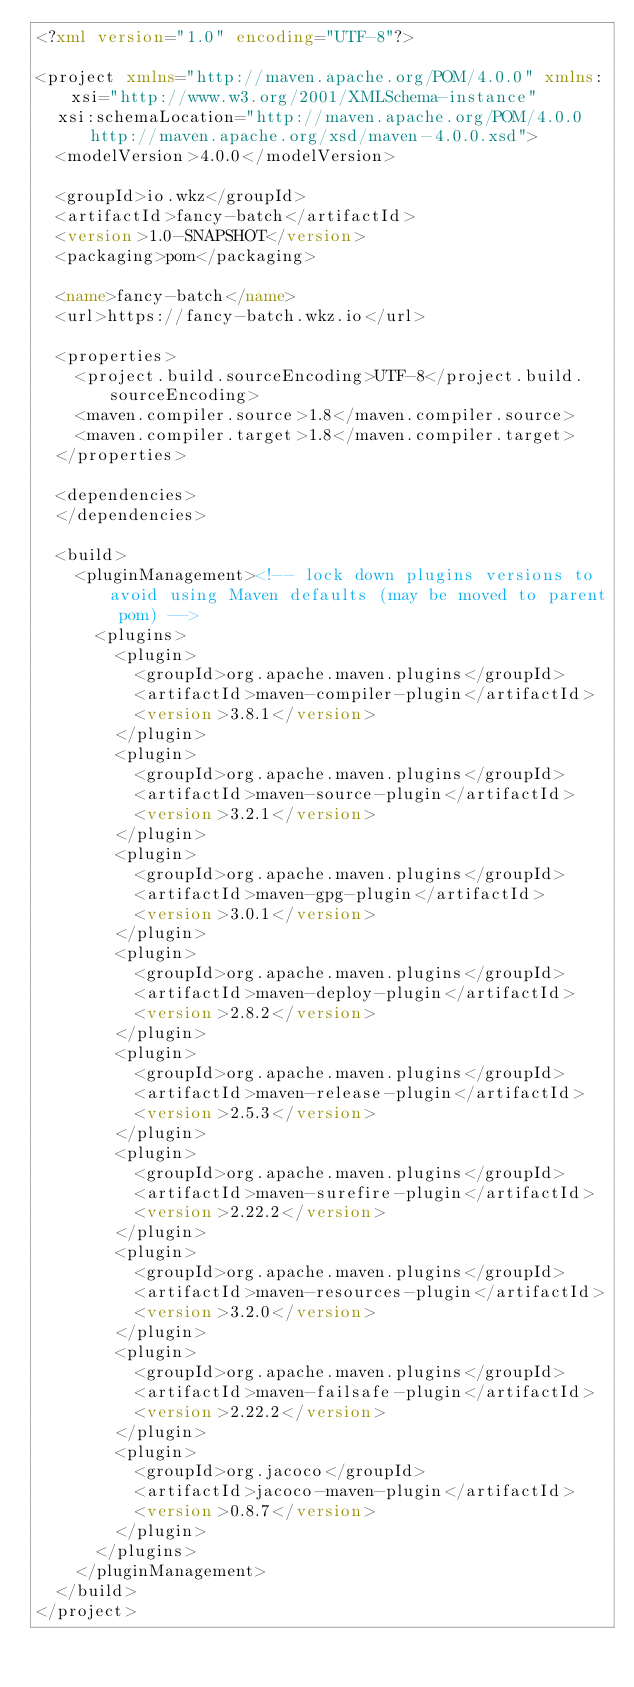<code> <loc_0><loc_0><loc_500><loc_500><_XML_><?xml version="1.0" encoding="UTF-8"?>

<project xmlns="http://maven.apache.org/POM/4.0.0" xmlns:xsi="http://www.w3.org/2001/XMLSchema-instance"
  xsi:schemaLocation="http://maven.apache.org/POM/4.0.0 http://maven.apache.org/xsd/maven-4.0.0.xsd">
  <modelVersion>4.0.0</modelVersion>

  <groupId>io.wkz</groupId>
  <artifactId>fancy-batch</artifactId>
  <version>1.0-SNAPSHOT</version>
  <packaging>pom</packaging>

  <name>fancy-batch</name>
  <url>https://fancy-batch.wkz.io</url>

  <properties>
    <project.build.sourceEncoding>UTF-8</project.build.sourceEncoding>
    <maven.compiler.source>1.8</maven.compiler.source>
    <maven.compiler.target>1.8</maven.compiler.target>
  </properties>

  <dependencies>
  </dependencies>

  <build>
    <pluginManagement><!-- lock down plugins versions to avoid using Maven defaults (may be moved to parent pom) -->
      <plugins>
        <plugin>
          <groupId>org.apache.maven.plugins</groupId>
          <artifactId>maven-compiler-plugin</artifactId>
          <version>3.8.1</version>
        </plugin>
        <plugin>
          <groupId>org.apache.maven.plugins</groupId>
          <artifactId>maven-source-plugin</artifactId>
          <version>3.2.1</version>
        </plugin>
        <plugin>
          <groupId>org.apache.maven.plugins</groupId>
          <artifactId>maven-gpg-plugin</artifactId>
          <version>3.0.1</version>
        </plugin>
        <plugin>
          <groupId>org.apache.maven.plugins</groupId>
          <artifactId>maven-deploy-plugin</artifactId>
          <version>2.8.2</version>
        </plugin>
        <plugin>
          <groupId>org.apache.maven.plugins</groupId>
          <artifactId>maven-release-plugin</artifactId>
          <version>2.5.3</version>
        </plugin>
        <plugin>
          <groupId>org.apache.maven.plugins</groupId>
          <artifactId>maven-surefire-plugin</artifactId>
          <version>2.22.2</version>
        </plugin>
        <plugin>
          <groupId>org.apache.maven.plugins</groupId>
          <artifactId>maven-resources-plugin</artifactId>
          <version>3.2.0</version>
        </plugin>
        <plugin>
          <groupId>org.apache.maven.plugins</groupId>
          <artifactId>maven-failsafe-plugin</artifactId>
          <version>2.22.2</version>
        </plugin>
        <plugin>
          <groupId>org.jacoco</groupId>
          <artifactId>jacoco-maven-plugin</artifactId>
          <version>0.8.7</version>
        </plugin>
      </plugins>
    </pluginManagement>
  </build>
</project>
</code> 